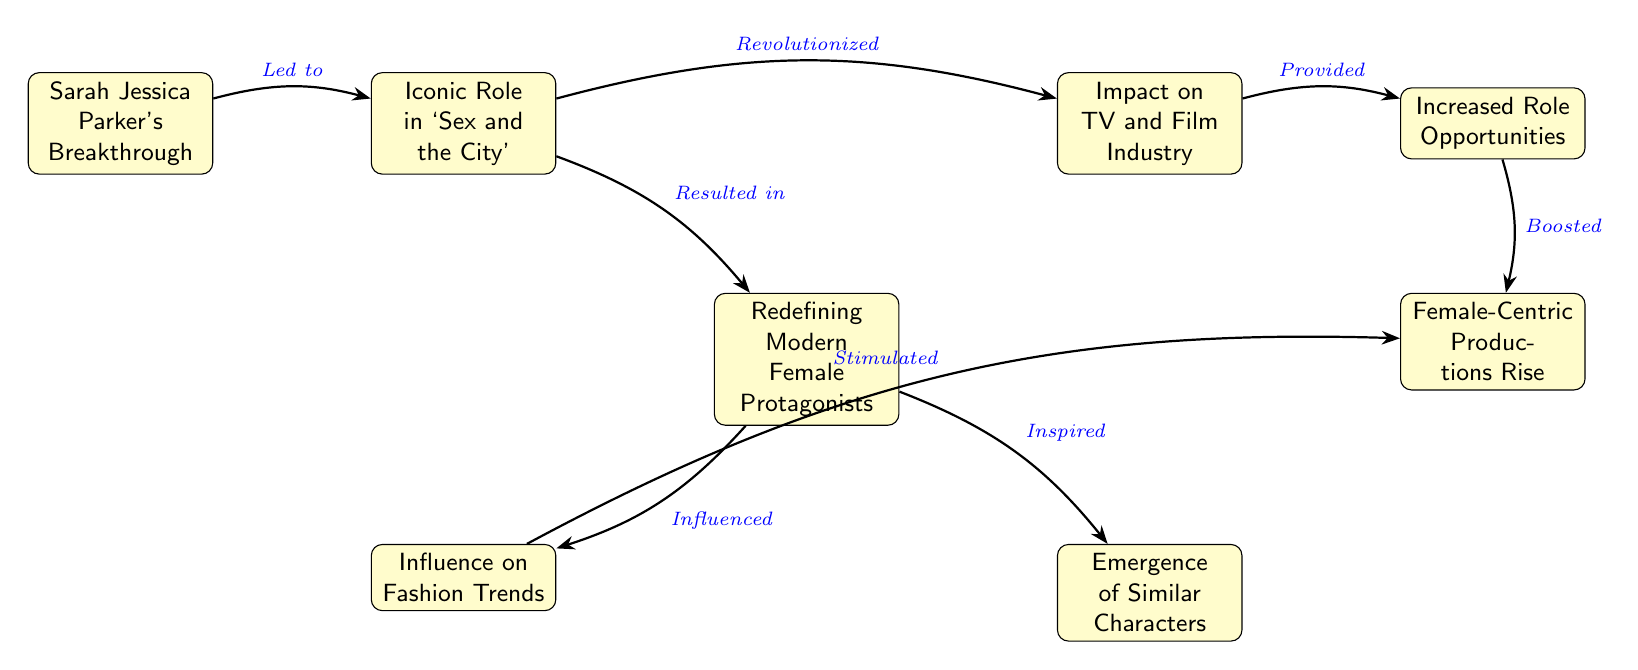What is the first node in the diagram? The first node in the diagram is found at the top. It is labeled "Sarah Jessica Parker's Breakthrough."
Answer: Sarah Jessica Parker's Breakthrough How many nodes are in the flowchart? To find the total number of nodes, we count each distinct box in the diagram, which gives us 8 nodes.
Answer: 8 What relationship does "Iconic Role in `Sex and the City`" have with "Redefining Modern Female Protagonists"? The relationship is defined by the phrase "Resulted in," indicating that the iconic role directly led to the redefinition of modern female protagonists.
Answer: Resulted in Which node follows "Impact on TV and Film Industry"? The node that follows "Impact on TV and Film Industry" is "Increased Role Opportunities," as shown by the directed arrow going out from the former to the latter.
Answer: Increased Role Opportunities What effect did "Redefining Modern Female Protagonists" have on "Influence on Fashion Trends"? The effect is conveyed through the connection labeled "Influenced," meaning that the redefinition directly impacted fashion trends.
Answer: Influenced How does "Influence on Fashion Trends" contribute to the diagram? It is connected to "Female-Centric Productions Rise" through the relationship "Stimulated," indicating that the fashion influence is a catalyst for more female-centric productions.
Answer: Stimulated What does "Emergence of Similar Characters" represent in the context of this diagram? It represents a concept that is inspired by "Redefining Modern Female Protagonists."  This means that the emerging characters are a result of the changes brought about in that node.
Answer: Inspired How do "Increased Role Opportunities" and "Female-Centric Productions Rise" relate to each other? "Increased Role Opportunities" provides a boost to "Female-Centric Productions Rise," meaning that the growing opportunities for roles have a positive effect on the rise of female-centric productions.
Answer: Boosted 